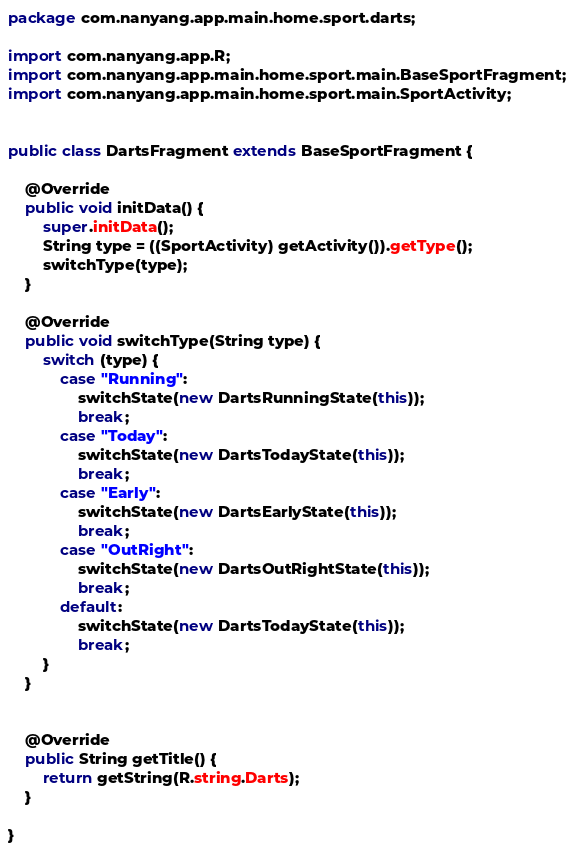<code> <loc_0><loc_0><loc_500><loc_500><_Java_>package com.nanyang.app.main.home.sport.darts;

import com.nanyang.app.R;
import com.nanyang.app.main.home.sport.main.BaseSportFragment;
import com.nanyang.app.main.home.sport.main.SportActivity;


public class DartsFragment extends BaseSportFragment {

    @Override
    public void initData() {
        super.initData();
        String type = ((SportActivity) getActivity()).getType();
        switchType(type);
    }

    @Override
    public void switchType(String type) {
        switch (type) {
            case "Running":
                switchState(new DartsRunningState(this));
                break;
            case "Today":
                switchState(new DartsTodayState(this));
                break;
            case "Early":
                switchState(new DartsEarlyState(this));
                break;
            case "OutRight":
                switchState(new DartsOutRightState(this));
                break;
            default:
                switchState(new DartsTodayState(this));
                break;
        }
    }


    @Override
    public String getTitle() {
        return getString(R.string.Darts);
    }

}
</code> 